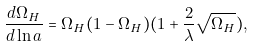<formula> <loc_0><loc_0><loc_500><loc_500>\frac { d \Omega _ { H } } { d \ln a } = \Omega _ { H } ( 1 - \Omega _ { H } ) ( 1 + \frac { 2 } { \lambda } \sqrt { \Omega _ { H } } ) ,</formula> 